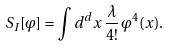Convert formula to latex. <formula><loc_0><loc_0><loc_500><loc_500>S _ { I } [ \varphi ] = \int d ^ { d } x \, \frac { \lambda } { 4 ! } \, \varphi ^ { 4 } ( x ) .</formula> 